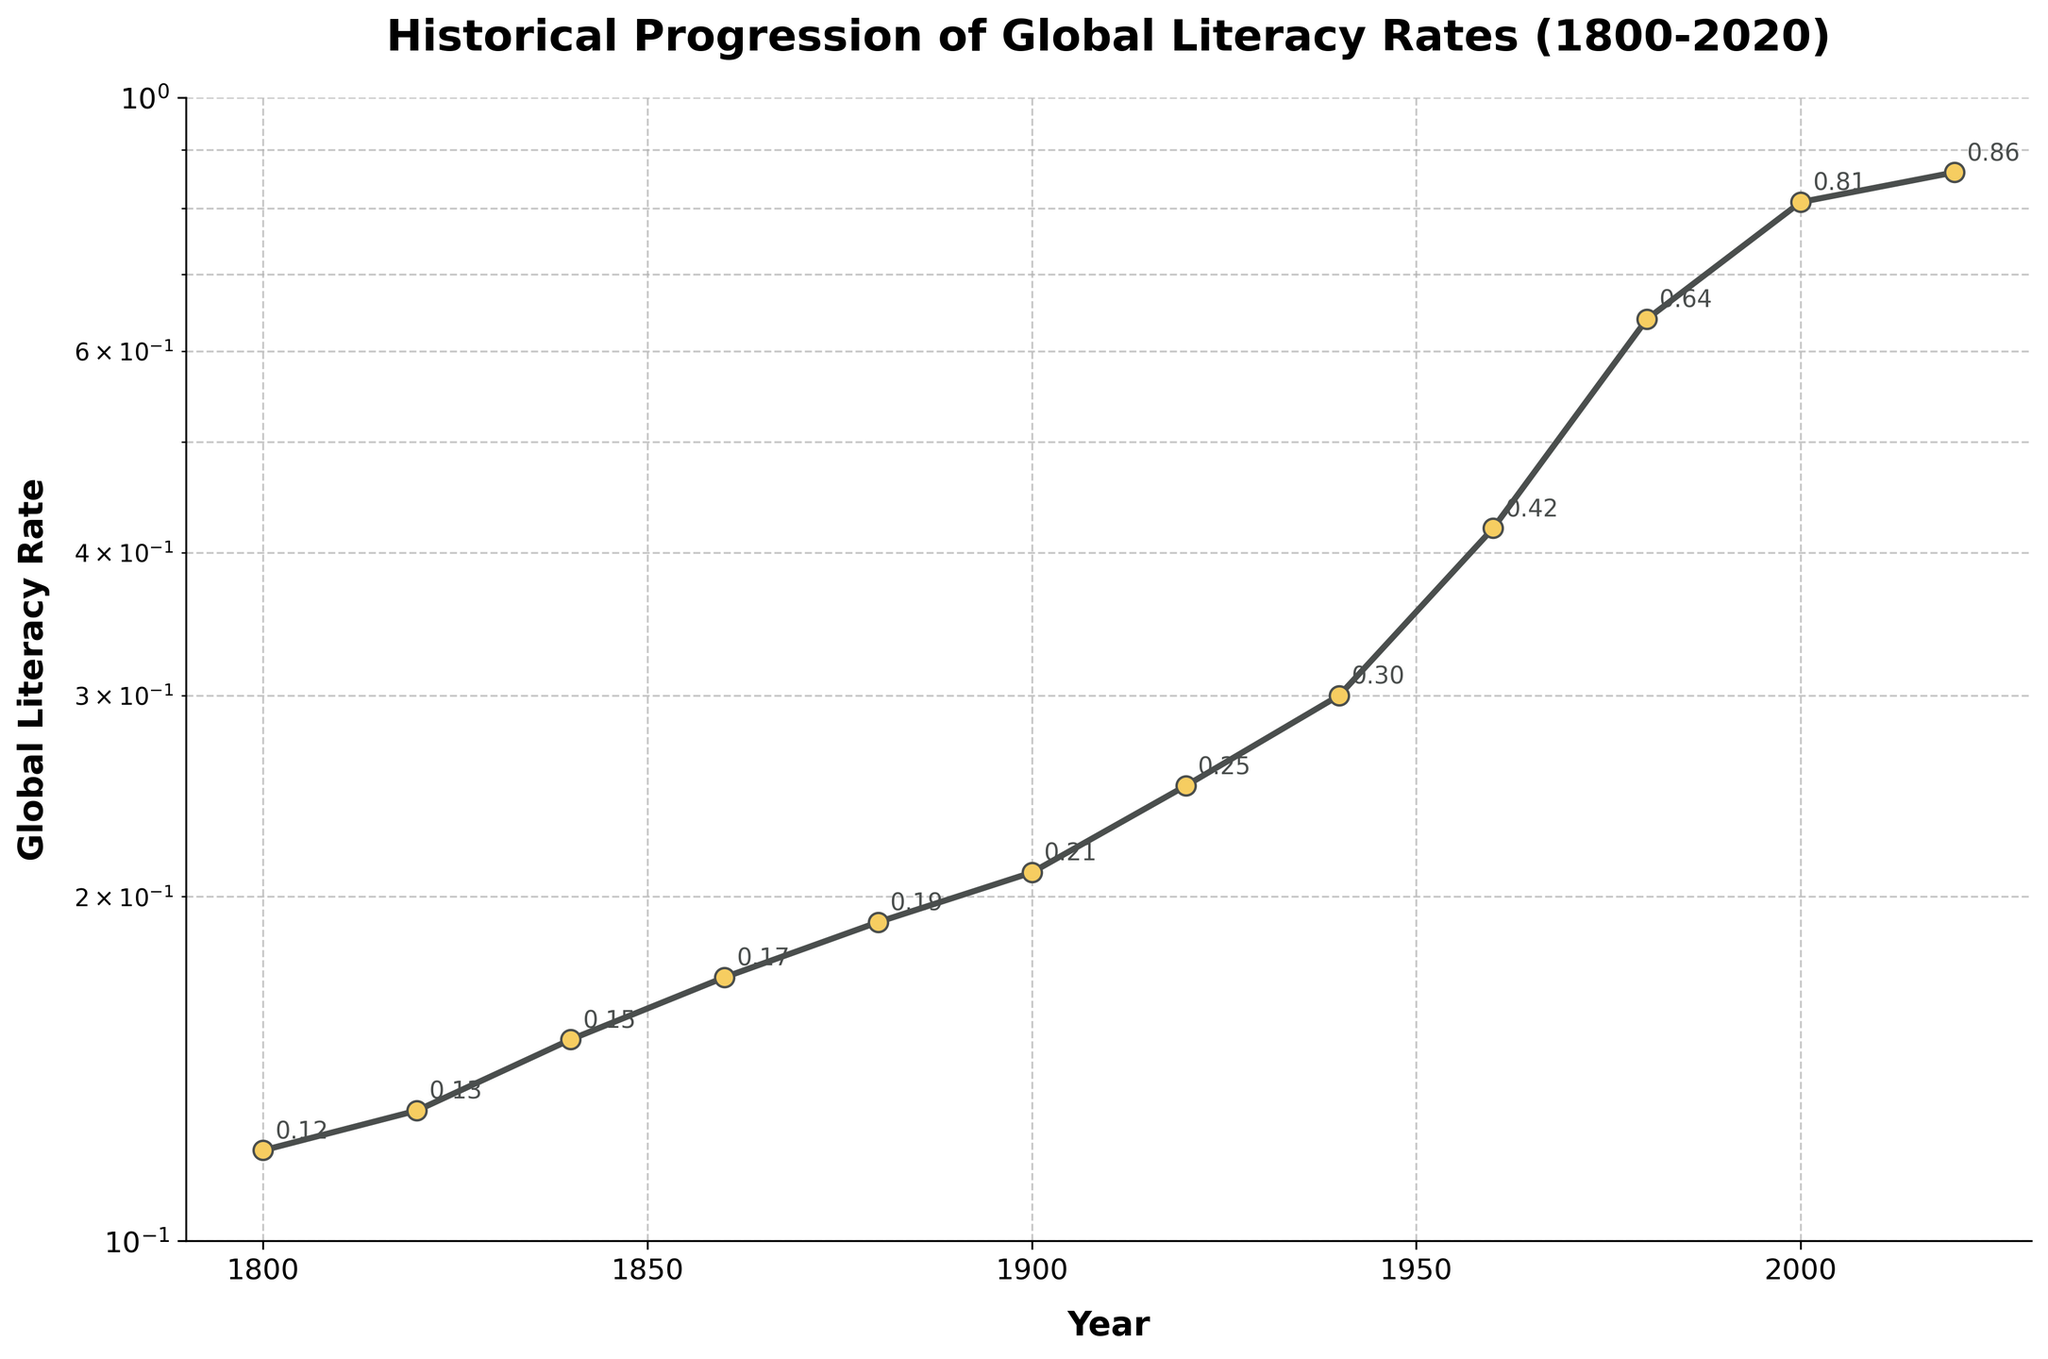What is the title of the figure? The title of the figure is written at the top of the plot.
Answer: Historical Progression of Global Literacy Rates (1800-2020) How many data points are there in the figure? By counting the markers on the line plot, you can see there are twelve data points.
Answer: Twelve What is the global literacy rate in 2000? Locate the year 2000 on the x-axis and see the corresponding y-value on the plot. It is around 0.81, as annotated near the marker.
Answer: 0.81 What is the range of the global literacy rate from 1800 to 2020? Find the minimum and maximum global literacy rates in the plot, which are 0.12 in 1800 and 0.86 in 2020 respectively. The range is the difference between these values.
Answer: 0.74 When did the global literacy rate experience its most significant jump? Compare the differences between consecutive data points. The largest increase appears between 1940 (0.30) and 1960 (0.42), an increase of 0.12.
Answer: 1940 to 1960 Which year had a global literacy rate closest to 0.20? Look at the y-axis and locate the value closest to 0.20. The closest annotated marker is at 0.21 for the year 1900.
Answer: 1900 How has the global literacy rate changed from 1800 to 1920? Evaluate the plot from 1800 to 1920. The global literacy rate increased from 0.12 in 1800 to 0.25 in 1920.
Answer: Increased How much has the global literacy rate increased per decade on average from 1960 to 2020? Calculate the difference between the rates in 1960 (0.42) and 2020 (0.86), which is 0.44, then divide by the number of decades (6), giving 0.44/6 ≈ 0.0733.
Answer: Approximately 0.0733 What is the logarithmic scale range on the y-axis? Observe the y-axis where the logarithmic scale is set from 0.1 to 1.
Answer: 0.1 to 1 Which period had the slowest growth in literacy rates? Identify the periods with the smallest changes in literacy rates. From 1800 to 1880, the rate increased only from 0.12 to 0.19, which is the slowest growth.
Answer: 1800 to 1880 